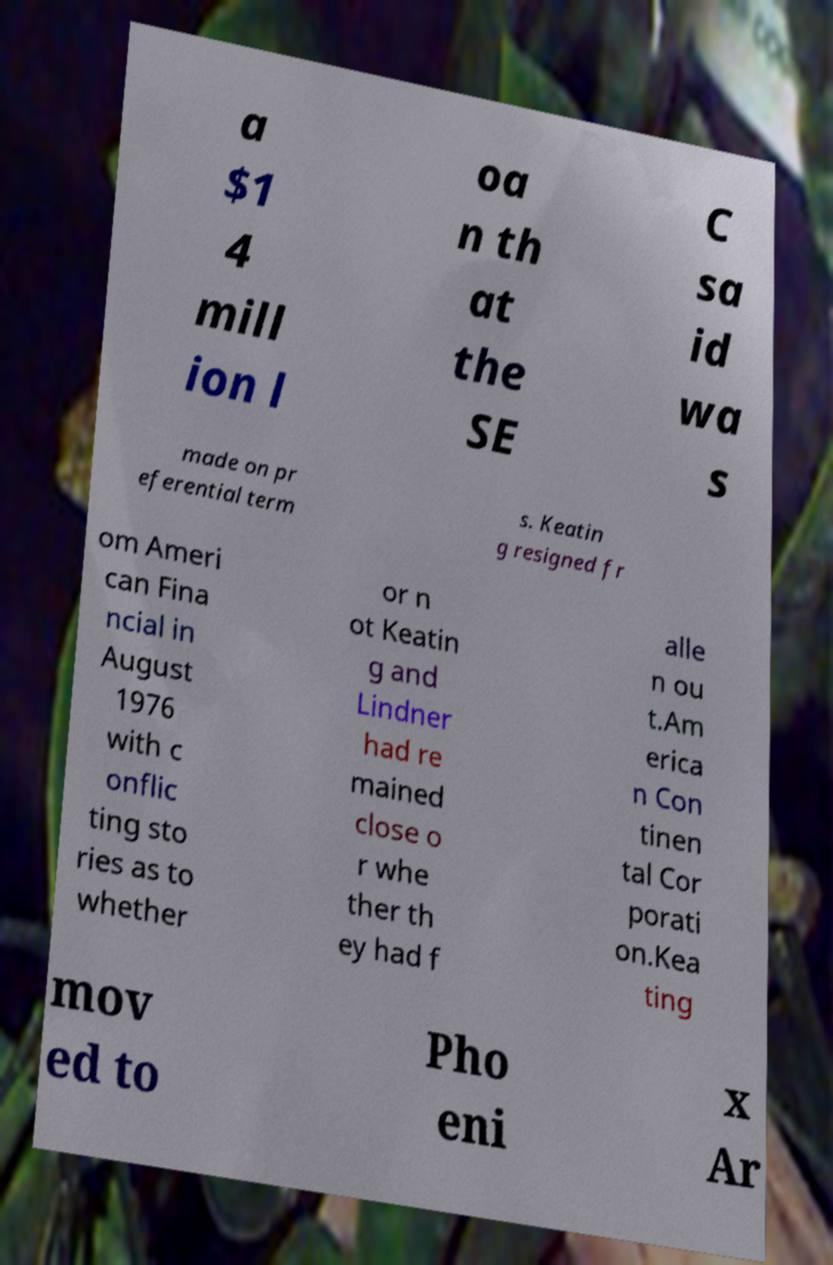Could you extract and type out the text from this image? a $1 4 mill ion l oa n th at the SE C sa id wa s made on pr eferential term s. Keatin g resigned fr om Ameri can Fina ncial in August 1976 with c onflic ting sto ries as to whether or n ot Keatin g and Lindner had re mained close o r whe ther th ey had f alle n ou t.Am erica n Con tinen tal Cor porati on.Kea ting mov ed to Pho eni x Ar 